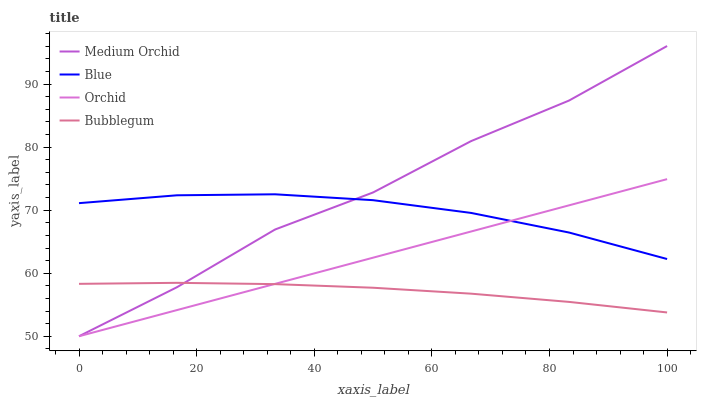Does Bubblegum have the minimum area under the curve?
Answer yes or no. Yes. Does Medium Orchid have the maximum area under the curve?
Answer yes or no. Yes. Does Medium Orchid have the minimum area under the curve?
Answer yes or no. No. Does Bubblegum have the maximum area under the curve?
Answer yes or no. No. Is Orchid the smoothest?
Answer yes or no. Yes. Is Medium Orchid the roughest?
Answer yes or no. Yes. Is Bubblegum the smoothest?
Answer yes or no. No. Is Bubblegum the roughest?
Answer yes or no. No. Does Medium Orchid have the lowest value?
Answer yes or no. No. Does Medium Orchid have the highest value?
Answer yes or no. Yes. Does Bubblegum have the highest value?
Answer yes or no. No. Is Bubblegum less than Blue?
Answer yes or no. Yes. Is Medium Orchid greater than Orchid?
Answer yes or no. Yes. Does Bubblegum intersect Medium Orchid?
Answer yes or no. Yes. Is Bubblegum less than Medium Orchid?
Answer yes or no. No. Is Bubblegum greater than Medium Orchid?
Answer yes or no. No. Does Bubblegum intersect Blue?
Answer yes or no. No. 